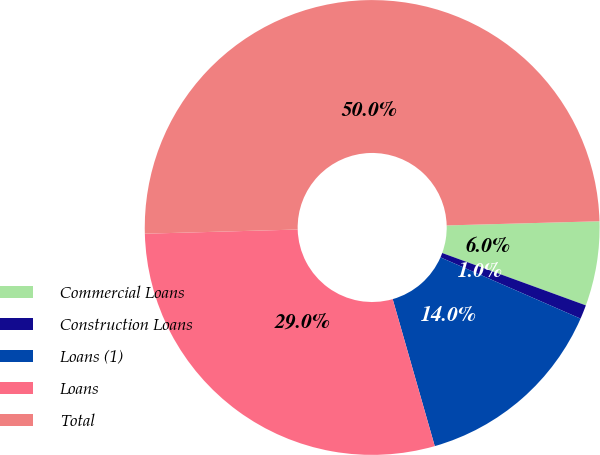Convert chart to OTSL. <chart><loc_0><loc_0><loc_500><loc_500><pie_chart><fcel>Commercial Loans<fcel>Construction Loans<fcel>Loans (1)<fcel>Loans<fcel>Total<nl><fcel>6.0%<fcel>1.0%<fcel>14.0%<fcel>29.0%<fcel>50.0%<nl></chart> 